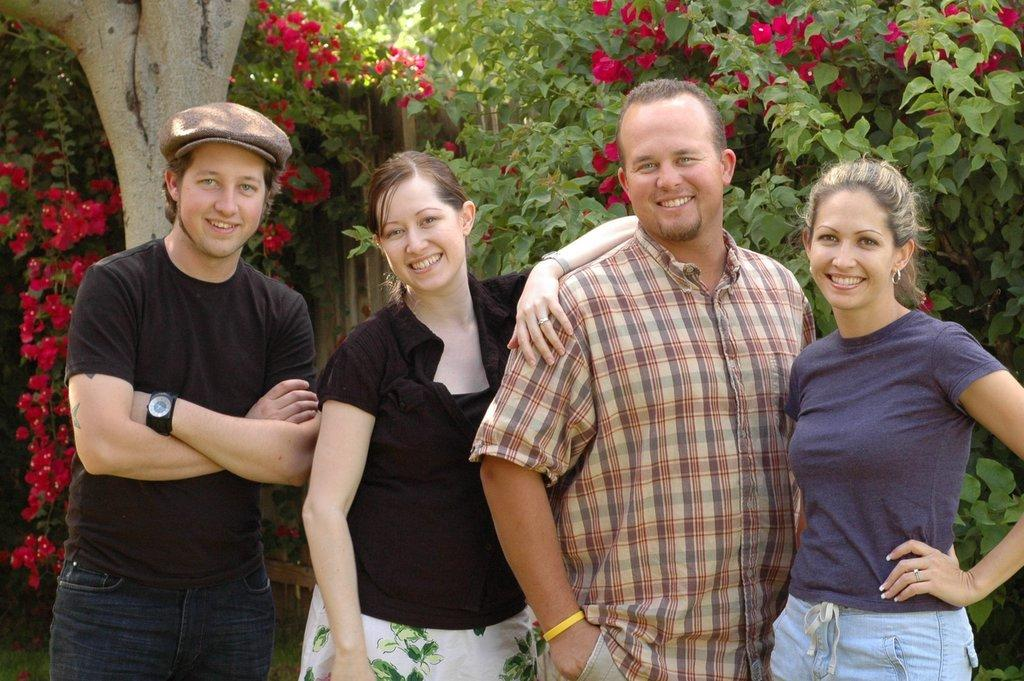How many people are in the image? There is a group of persons in the image. What are the people in the image doing? The persons are standing and smiling. What can be seen in the background of the image? There are trees in the background of the image. What color or type of flowers are present in the image? There are pink flowers in the image. How many umbrellas are being used by the persons in the image? There is no mention of umbrellas in the image; the focus is on the group of persons, their actions, and the presence of trees and pink flowers. 